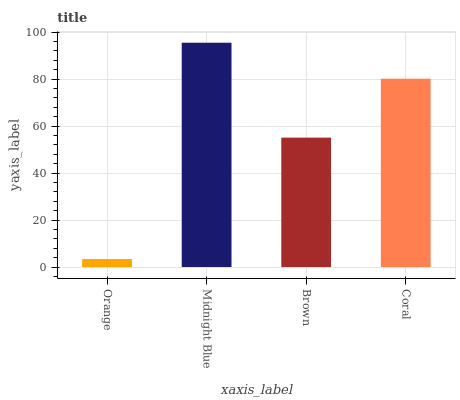Is Orange the minimum?
Answer yes or no. Yes. Is Midnight Blue the maximum?
Answer yes or no. Yes. Is Brown the minimum?
Answer yes or no. No. Is Brown the maximum?
Answer yes or no. No. Is Midnight Blue greater than Brown?
Answer yes or no. Yes. Is Brown less than Midnight Blue?
Answer yes or no. Yes. Is Brown greater than Midnight Blue?
Answer yes or no. No. Is Midnight Blue less than Brown?
Answer yes or no. No. Is Coral the high median?
Answer yes or no. Yes. Is Brown the low median?
Answer yes or no. Yes. Is Orange the high median?
Answer yes or no. No. Is Coral the low median?
Answer yes or no. No. 